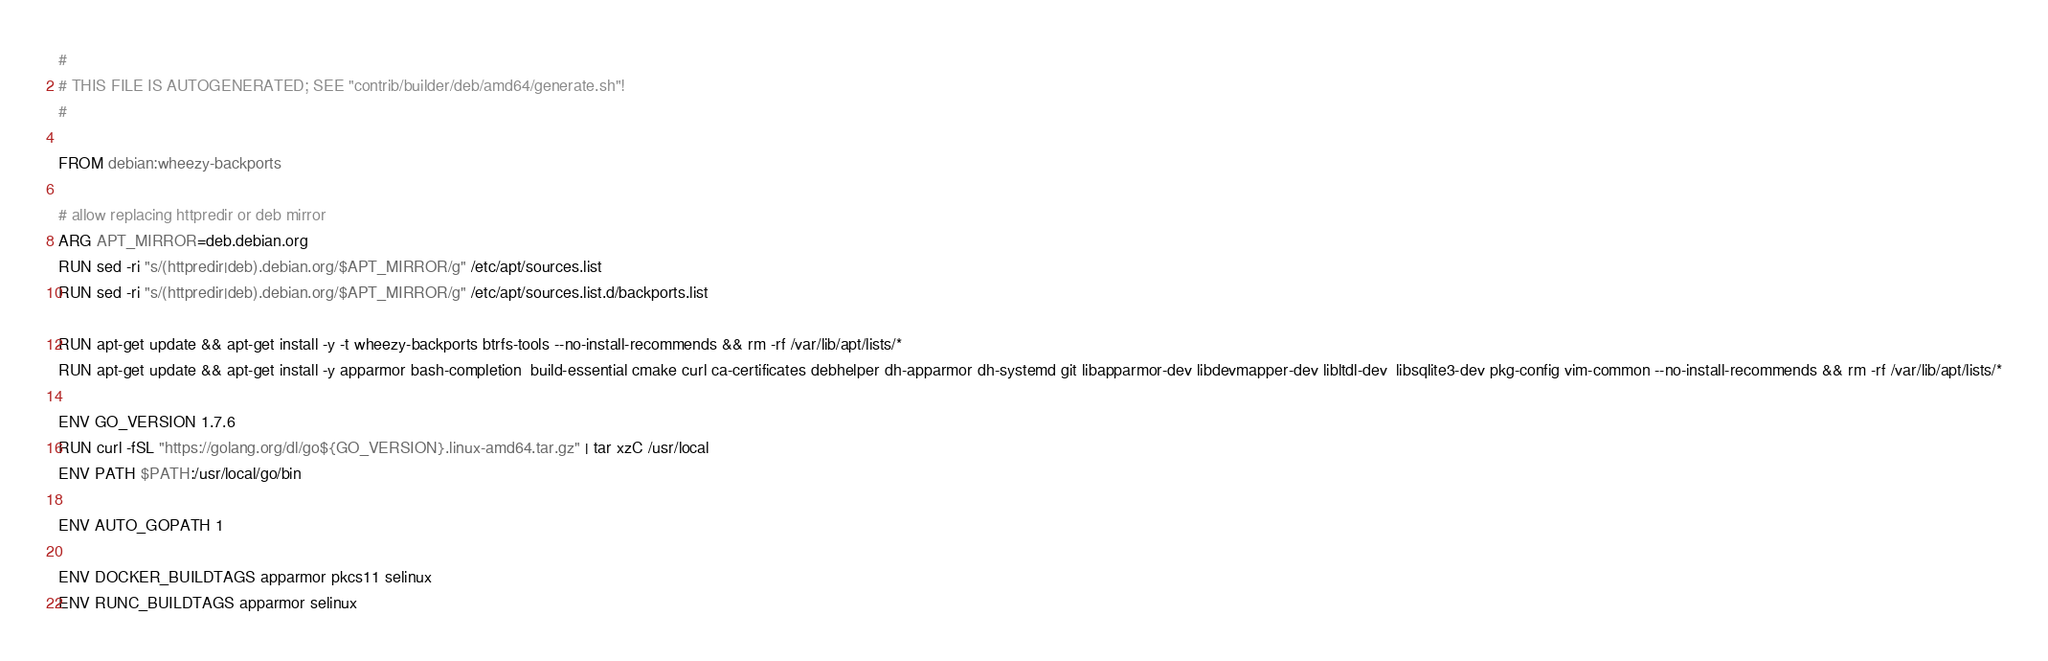Convert code to text. <code><loc_0><loc_0><loc_500><loc_500><_Dockerfile_>#
# THIS FILE IS AUTOGENERATED; SEE "contrib/builder/deb/amd64/generate.sh"!
#

FROM debian:wheezy-backports

# allow replacing httpredir or deb mirror
ARG APT_MIRROR=deb.debian.org
RUN sed -ri "s/(httpredir|deb).debian.org/$APT_MIRROR/g" /etc/apt/sources.list
RUN sed -ri "s/(httpredir|deb).debian.org/$APT_MIRROR/g" /etc/apt/sources.list.d/backports.list

RUN apt-get update && apt-get install -y -t wheezy-backports btrfs-tools --no-install-recommends && rm -rf /var/lib/apt/lists/*
RUN apt-get update && apt-get install -y apparmor bash-completion  build-essential cmake curl ca-certificates debhelper dh-apparmor dh-systemd git libapparmor-dev libdevmapper-dev libltdl-dev  libsqlite3-dev pkg-config vim-common --no-install-recommends && rm -rf /var/lib/apt/lists/*

ENV GO_VERSION 1.7.6
RUN curl -fSL "https://golang.org/dl/go${GO_VERSION}.linux-amd64.tar.gz" | tar xzC /usr/local
ENV PATH $PATH:/usr/local/go/bin

ENV AUTO_GOPATH 1

ENV DOCKER_BUILDTAGS apparmor pkcs11 selinux
ENV RUNC_BUILDTAGS apparmor selinux
</code> 